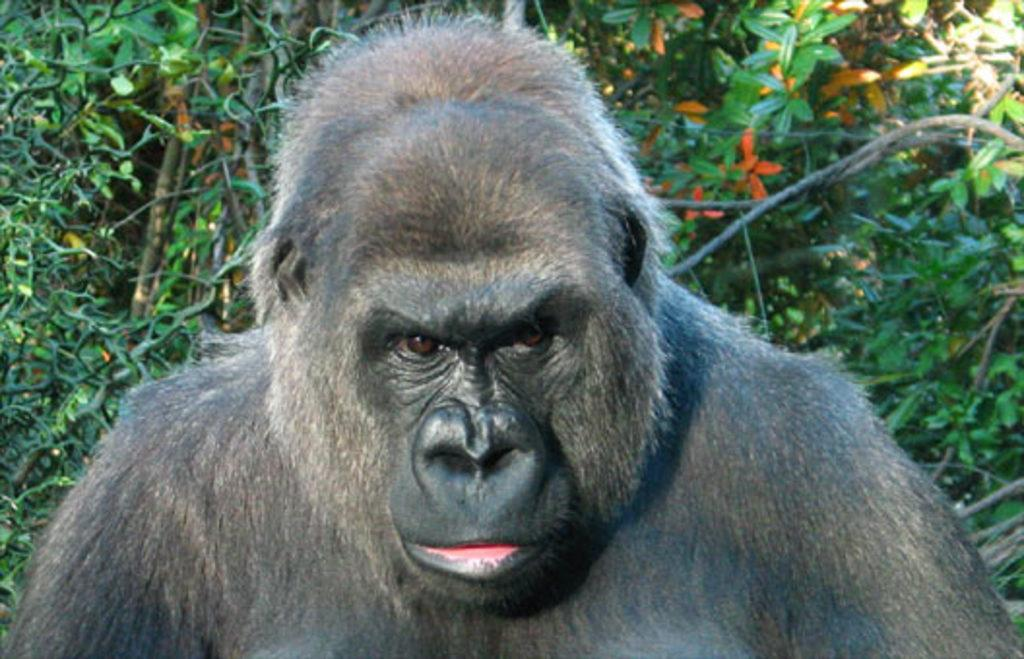What animal is the main subject of the picture? There is a gorilla in the picture. Where is the gorilla located in relation to the plants? The gorilla is sitting near to the plants. What type of flowers can be seen on the plants? There are orange flowers on the plants. What historical event is depicted in the image? There is no historical event depicted in the image; it features a gorilla sitting near plants with orange flowers. How many things can be seen in the basket in the image? There is no basket present in the image. 